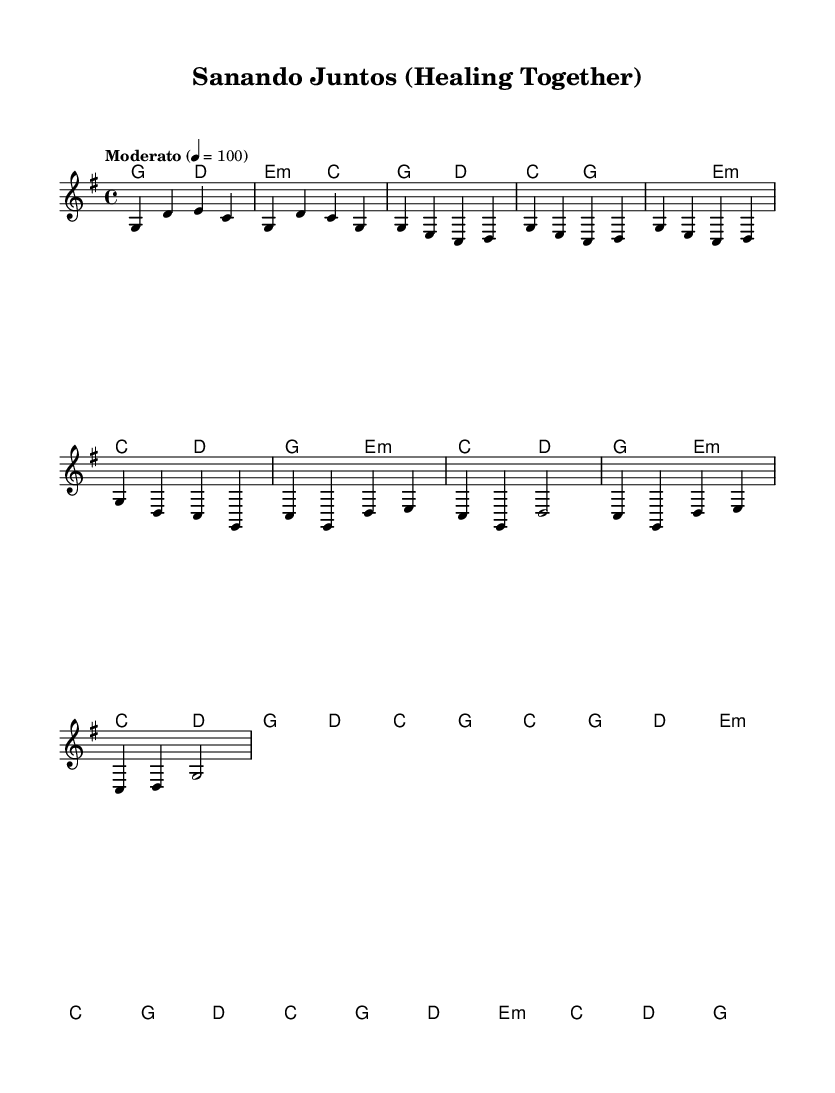What is the key signature of this music? The key signature indicated in the sheet music is G major, which has one sharp (F#). We identify the key signature by looking at the beginning of the staff, where it displays the sharp.
Answer: G major What is the time signature of this piece? The time signature is 4/4, which means there are four beats per measure and the quarter note gets one beat. We can determine this from the notation found at the beginning of the measure.
Answer: 4/4 What is the tempo marking for this piece? The tempo marking is "Moderato," which indicates a moderate pace. It is specified above the staff and gives performers a guideline for the speed of the piece.
Answer: Moderato How many measures are in the verse section? There are eight measures in the verse section, as counted from the respective part of the music which outlines this section after the intro.
Answer: 8 What chord is played at the start of the chorus? The first chord played in the chorus is C major, as indicated in the chord changes aligned above the staff. We can see the chord representation at the start of the chorus segment.
Answer: C major Is there a repeated melody section in this piece? Yes, the melody in the verse section is repeated throughout, specifically the phrase that starts with G and features a pattern of pitches that recur. This observation can be made by noticing identical sequences in the melody lines.
Answer: Yes How does the harmony change in the chorus compared to the verse? In the chorus, the harmony features C major and D minor more prominently than in the verse, which utilizes G major and E minor more frequently. This can be seen by comparing the chord progressions in both sections.
Answer: More C major and D minor 